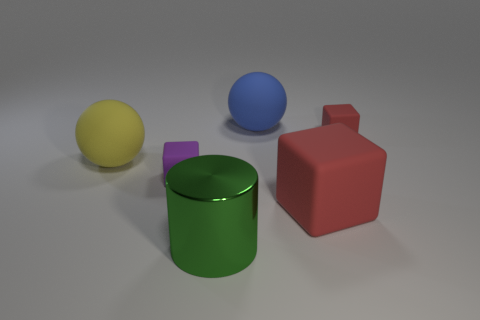Are there any other things that have the same material as the green cylinder?
Give a very brief answer. No. Do the small thing to the left of the big blue sphere and the large blue object have the same material?
Offer a terse response. Yes. What is the size of the object that is in front of the purple rubber thing and behind the green thing?
Keep it short and to the point. Large. What color is the big block?
Your answer should be compact. Red. What number of small cyan rubber objects are there?
Offer a very short reply. 0. What number of other rubber cubes are the same color as the big block?
Provide a short and direct response. 1. Does the small rubber thing that is in front of the large yellow ball have the same shape as the big yellow object that is behind the large cylinder?
Provide a short and direct response. No. There is a rubber cube on the left side of the red matte block in front of the big matte sphere that is to the left of the large metal cylinder; what color is it?
Your answer should be very brief. Purple. There is a block on the left side of the green shiny thing; what is its color?
Make the answer very short. Purple. What is the color of the other object that is the same size as the purple rubber object?
Provide a succinct answer. Red. 